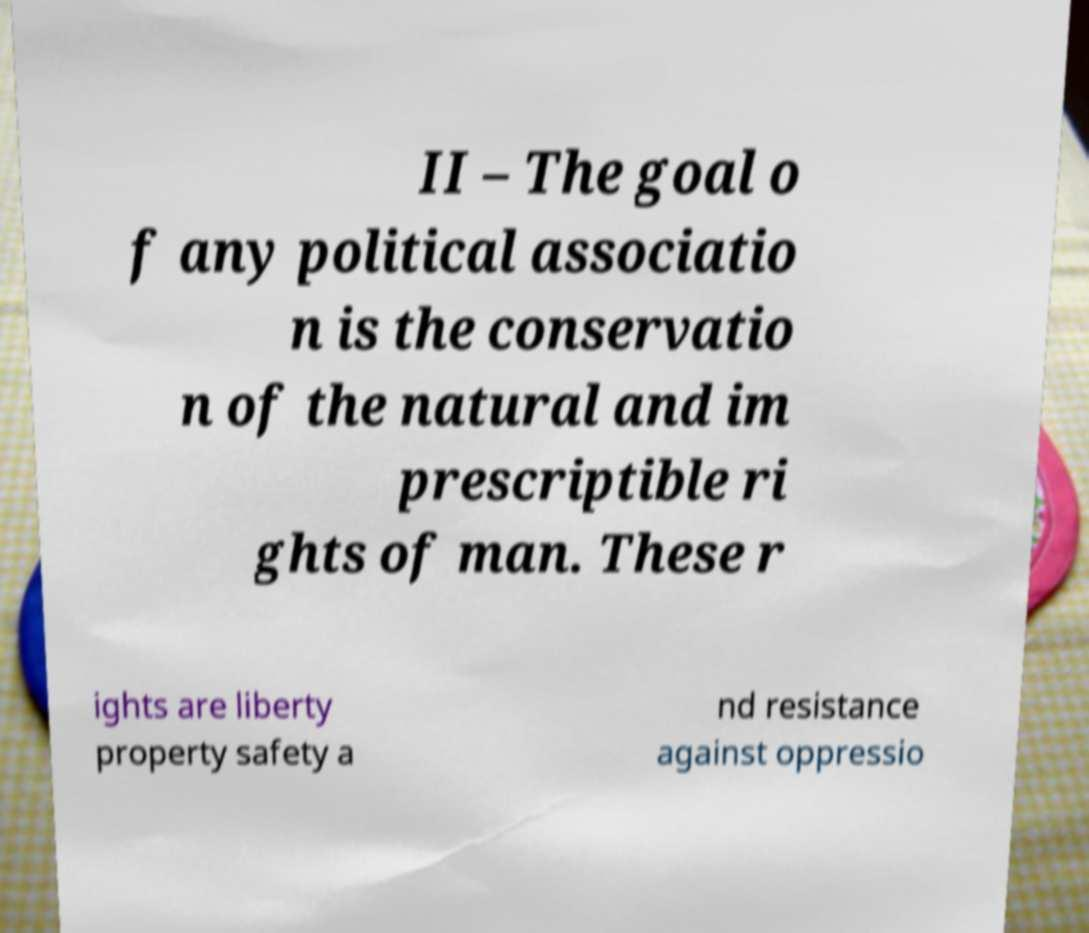Can you accurately transcribe the text from the provided image for me? II – The goal o f any political associatio n is the conservatio n of the natural and im prescriptible ri ghts of man. These r ights are liberty property safety a nd resistance against oppressio 